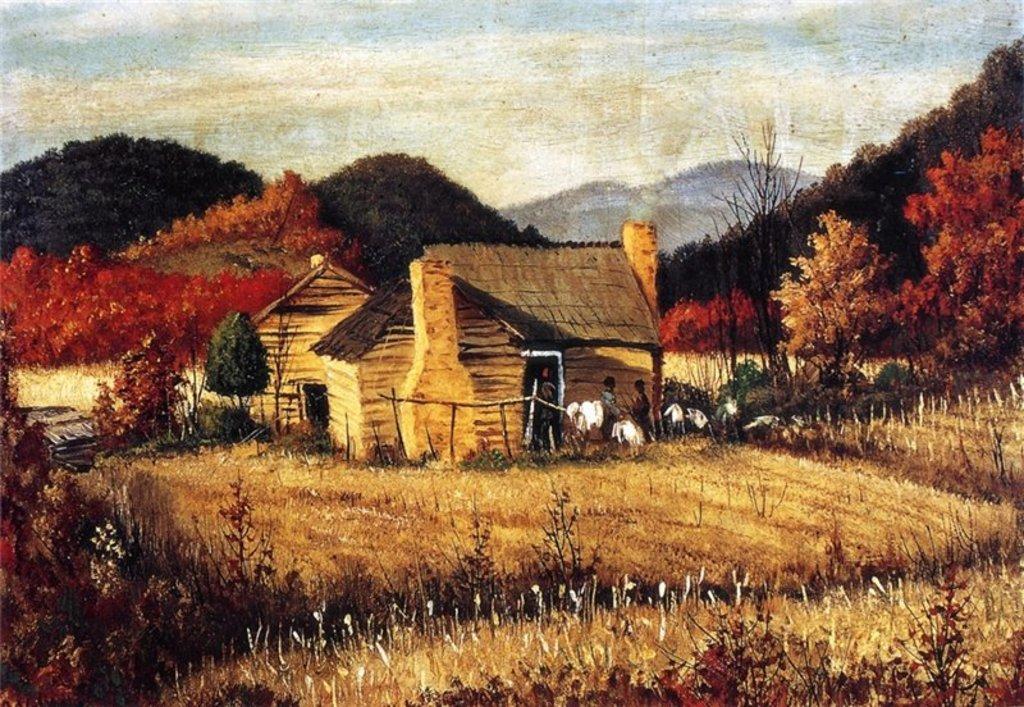Describe this image in one or two sentences. In this image I can see it is a painting, in the middle there are huts and there are few persons, at the back side there are trees. At the top it is the sky. 